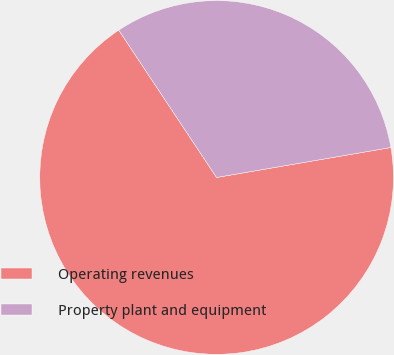Convert chart. <chart><loc_0><loc_0><loc_500><loc_500><pie_chart><fcel>Operating revenues<fcel>Property plant and equipment<nl><fcel>68.38%<fcel>31.62%<nl></chart> 